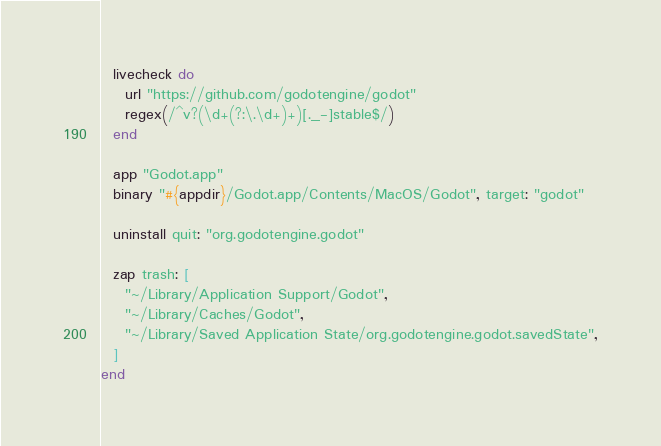<code> <loc_0><loc_0><loc_500><loc_500><_Ruby_>  livecheck do
    url "https://github.com/godotengine/godot"
    regex(/^v?(\d+(?:\.\d+)+)[._-]stable$/)
  end

  app "Godot.app"
  binary "#{appdir}/Godot.app/Contents/MacOS/Godot", target: "godot"

  uninstall quit: "org.godotengine.godot"

  zap trash: [
    "~/Library/Application Support/Godot",
    "~/Library/Caches/Godot",
    "~/Library/Saved Application State/org.godotengine.godot.savedState",
  ]
end
</code> 